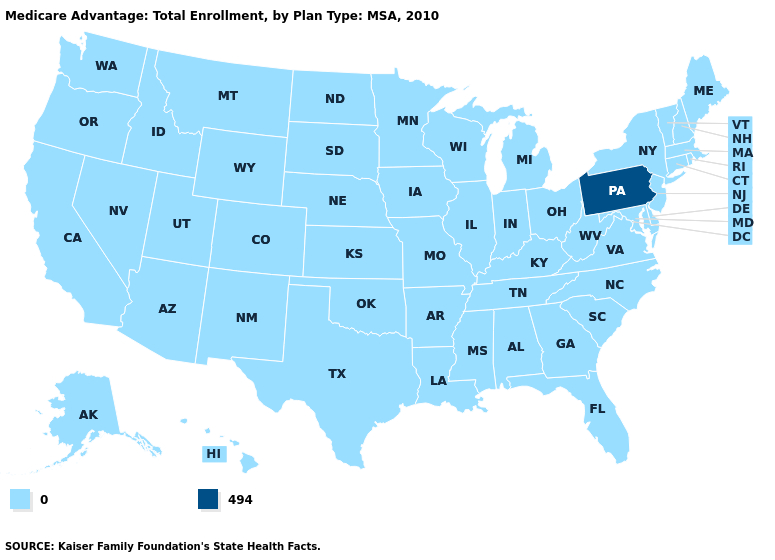Name the states that have a value in the range 0?
Concise answer only. Alaska, Alabama, Arkansas, Arizona, California, Colorado, Connecticut, Delaware, Florida, Georgia, Hawaii, Iowa, Idaho, Illinois, Indiana, Kansas, Kentucky, Louisiana, Massachusetts, Maryland, Maine, Michigan, Minnesota, Missouri, Mississippi, Montana, North Carolina, North Dakota, Nebraska, New Hampshire, New Jersey, New Mexico, Nevada, New York, Ohio, Oklahoma, Oregon, Rhode Island, South Carolina, South Dakota, Tennessee, Texas, Utah, Virginia, Vermont, Washington, Wisconsin, West Virginia, Wyoming. What is the lowest value in the USA?
Concise answer only. 0. Name the states that have a value in the range 494?
Quick response, please. Pennsylvania. Among the states that border Louisiana , which have the lowest value?
Concise answer only. Arkansas, Mississippi, Texas. What is the value of Wyoming?
Short answer required. 0. What is the value of Nevada?
Concise answer only. 0. Which states hav the highest value in the South?
Quick response, please. Alabama, Arkansas, Delaware, Florida, Georgia, Kentucky, Louisiana, Maryland, Mississippi, North Carolina, Oklahoma, South Carolina, Tennessee, Texas, Virginia, West Virginia. Name the states that have a value in the range 0?
Quick response, please. Alaska, Alabama, Arkansas, Arizona, California, Colorado, Connecticut, Delaware, Florida, Georgia, Hawaii, Iowa, Idaho, Illinois, Indiana, Kansas, Kentucky, Louisiana, Massachusetts, Maryland, Maine, Michigan, Minnesota, Missouri, Mississippi, Montana, North Carolina, North Dakota, Nebraska, New Hampshire, New Jersey, New Mexico, Nevada, New York, Ohio, Oklahoma, Oregon, Rhode Island, South Carolina, South Dakota, Tennessee, Texas, Utah, Virginia, Vermont, Washington, Wisconsin, West Virginia, Wyoming. Which states hav the highest value in the MidWest?
Quick response, please. Iowa, Illinois, Indiana, Kansas, Michigan, Minnesota, Missouri, North Dakota, Nebraska, Ohio, South Dakota, Wisconsin. Does Washington have the same value as Pennsylvania?
Keep it brief. No. What is the value of South Dakota?
Short answer required. 0. What is the value of Maryland?
Keep it brief. 0. Does the first symbol in the legend represent the smallest category?
Give a very brief answer. Yes. 